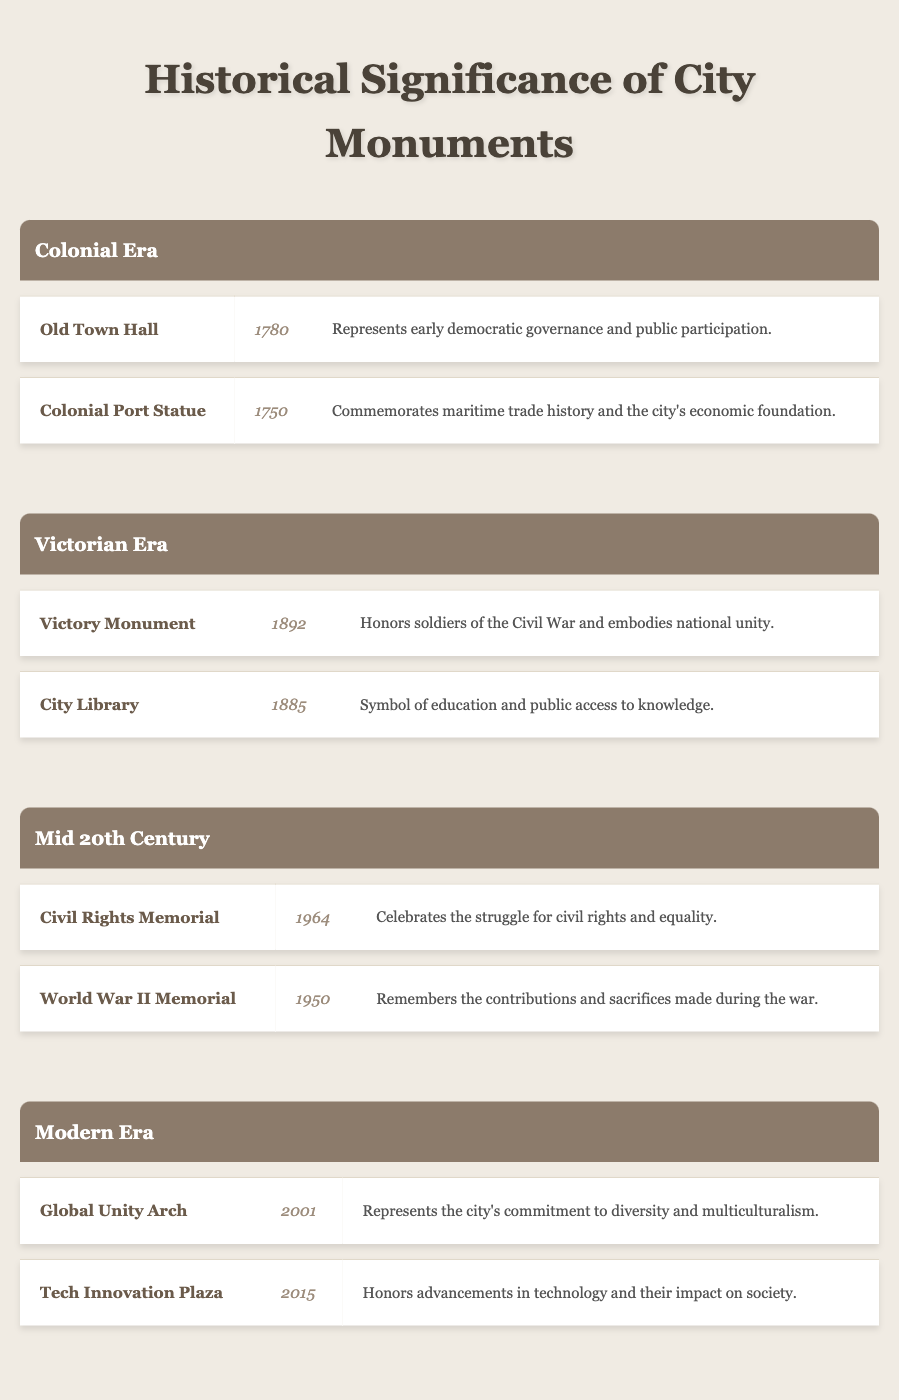What monument was established in 1780? According to the table, "Old Town Hall" is listed as the monument established in the year 1780.
Answer: Old Town Hall Which monument commemorates the Civil War? The table indicates that the "Victory Monument," established in 1892, honors soldiers of the Civil War.
Answer: Victory Monument Are there any monuments that honor advancements in technology? Yes, the "Tech Innovation Plaza," which was established in 2015, is listed as honoring advancements in technology.
Answer: Yes What is the significance of the Civil Rights Memorial? The table states that the Civil Rights Memorial celebrates the struggle for civil rights and equality.
Answer: Celebrates the struggle for civil rights and equality How many monuments were established in the Victorian Era? The table shows two monuments from the Victorian Era: "Victory Monument" and "City Library," thus the count is 2.
Answer: 2 Which era has a monument that represents the city's commitment to diversity? The table highlights the "Global Unity Arch," established in 2001, which is categorized under the Modern Era and represents the city's commitment to diversity.
Answer: Modern Era Which era has the oldest monument listed in the table? The oldest monument listed is "Colonial Port Statue," established in 1750, which belongs to the Colonial Era. To confirm, checking the establishment years for all eras shows the Colonial Era contains the earliest date.
Answer: Colonial Era What is the average year of establishment for the Mid 20th Century monuments? The years of establishment for the Mid 20th Century monuments are 1964 and 1950. Adding these years gives a total of 3214 and dividing by 2 gives an average year of 1607. Hence, the average year is calculated as (1964 + 1950) / 2 = 1957.
Answer: 1957 Is there a monument in the Modern Era that symbolizes education? No, the table indicates that there are no monuments related to education in the Modern Era; "Global Unity Arch" and "Tech Innovation Plaza" do not symbolize education.
Answer: No 